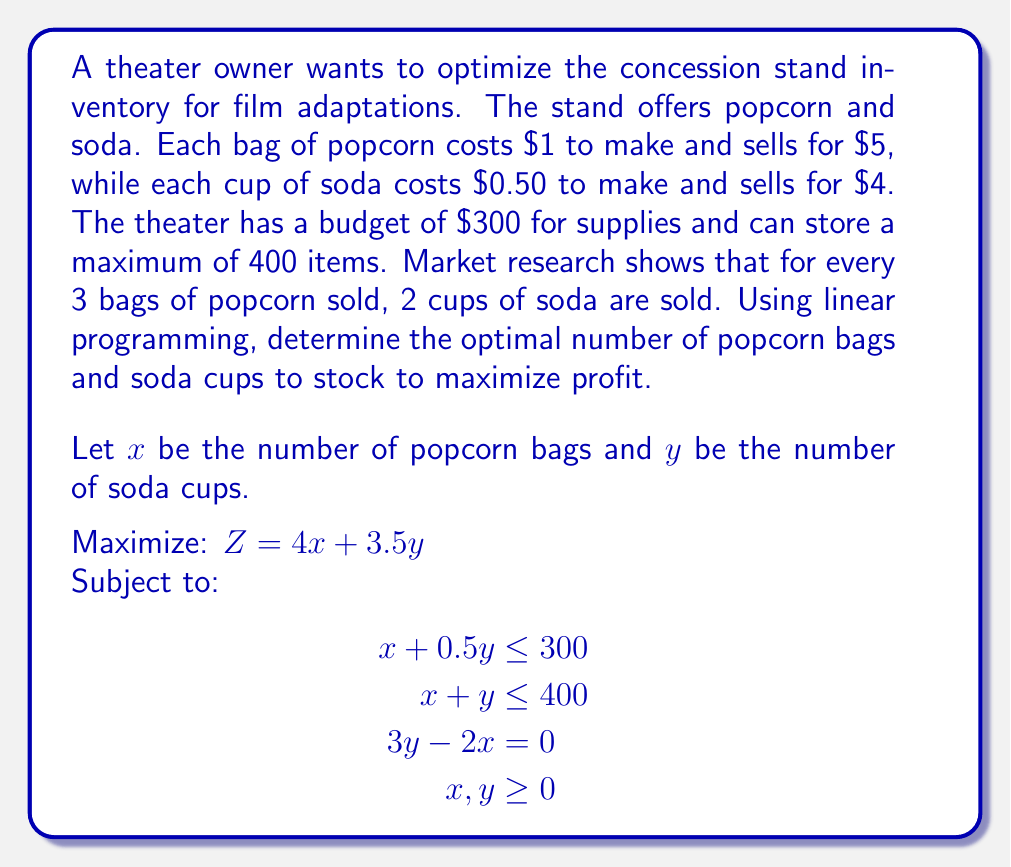Help me with this question. To solve this linear programming problem, we'll use the simplex method:

1. Convert the problem to standard form:
   Maximize: $Z = 4x + 3.5y$
   Subject to:
   $$\begin{aligned}
   x + 0.5y + s_1 &= 300 \\
   x + y + s_2 &= 400 \\
   3y - 2x &= 0 \\
   x, y, s_1, s_2 &\geq 0
   \end{aligned}$$

2. Create the initial tableau:
   $$\begin{array}{c|cccc|c}
   & x & y & s_1 & s_2 & RHS \\
   \hline
   s_1 & 1 & 0.5 & 1 & 0 & 300 \\
   s_2 & 1 & 1 & 0 & 1 & 400 \\
   0 & -2 & 3 & 0 & 0 & 0 \\
   \hline
   Z & -4 & -3.5 & 0 & 0 & 0
   \end{array}$$

3. Identify the pivot column (most negative in Z row): $x$
4. Calculate the ratios: $300/1 = 300$, $400/1 = 400$
5. Identify the pivot row (smallest positive ratio): first row
6. Perform row operations to make the pivot element 1 and other elements in the column 0

After several iterations, we reach the optimal solution:

$$\begin{array}{c|cccc|c}
& x & y & s_1 & s_2 & RHS \\
\hline
x & 1 & 0 & 0.6 & 0 & 240 \\
y & 0 & 1 & -0.4 & 0 & 160 \\
s_2 & 0 & 0 & -0.2 & 1 & 0 \\
\hline
Z & 0 & 0 & 1.4 & 0 & 1520
\end{array}$$

The optimal solution is $x = 240$ bags of popcorn and $y = 160$ cups of soda, with a maximum profit of $1520.
Answer: 240 bags of popcorn, 160 cups of soda 